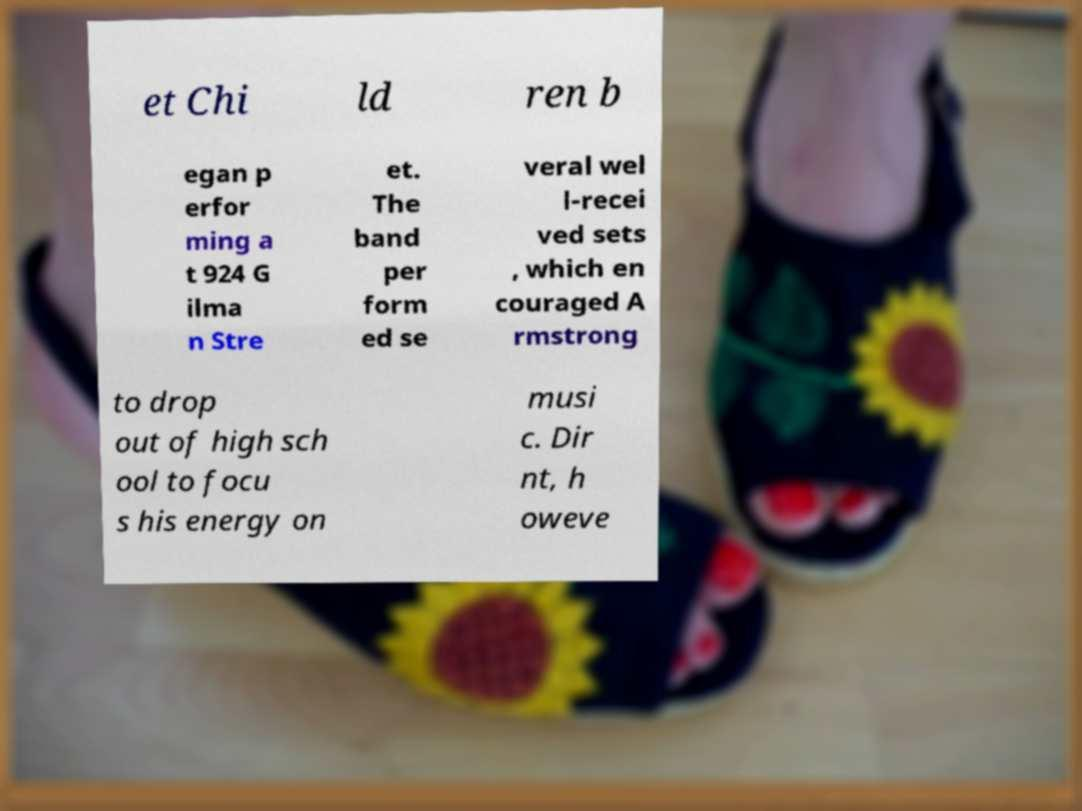Could you extract and type out the text from this image? et Chi ld ren b egan p erfor ming a t 924 G ilma n Stre et. The band per form ed se veral wel l-recei ved sets , which en couraged A rmstrong to drop out of high sch ool to focu s his energy on musi c. Dir nt, h oweve 